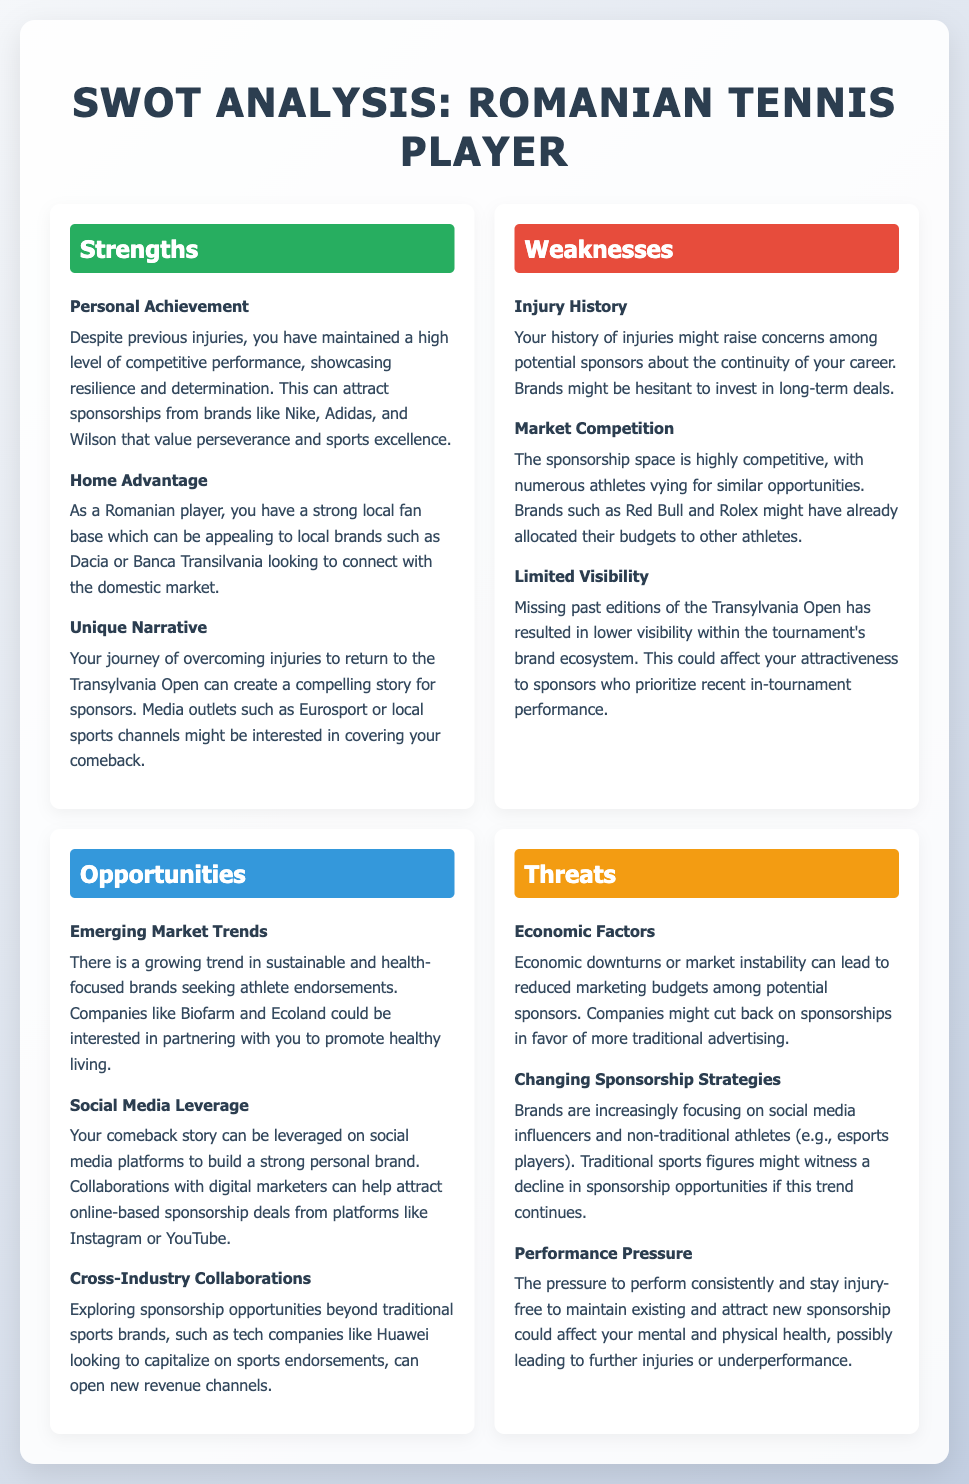What is a personal achievement mentioned? The personal achievement highlighted is the maintenance of a high level of competitive performance despite previous injuries.
Answer: Maintaining competitive performance Which local brand is mentioned as appealing to your fan base? The brand mentioned that could connect with the domestic market is Dacia.
Answer: Dacia What is a key weakness identified related to sponsorship? A key weakness is your history of injuries, which might raise concerns for sponsors.
Answer: Injury history Name an emerging market trend for sponsorship opportunities. The emerging trend noted is the interest of sustainable and health-focused brands seeking athlete endorsements.
Answer: Sustainable and health-focused brands What aspect can be leveraged for building a strong personal brand? Your comeback story can be leveraged on social media platforms.
Answer: Social media Which economic factor could threaten sponsorship opportunities? Economic downturns or market instability are threats that could reduce marketing budgets among sponsors.
Answer: Economic downturns What is a unique narrative highlighted for potential media interest? The journey of overcoming injuries to return to the Transylvania Open is identified as a compelling story.
Answer: Overcoming injuries What changing trend in sponsorship strategies is mentioned? Brands are focusing more on social media influencers and non-traditional athletes, like esports players.
Answer: Social media influencers 